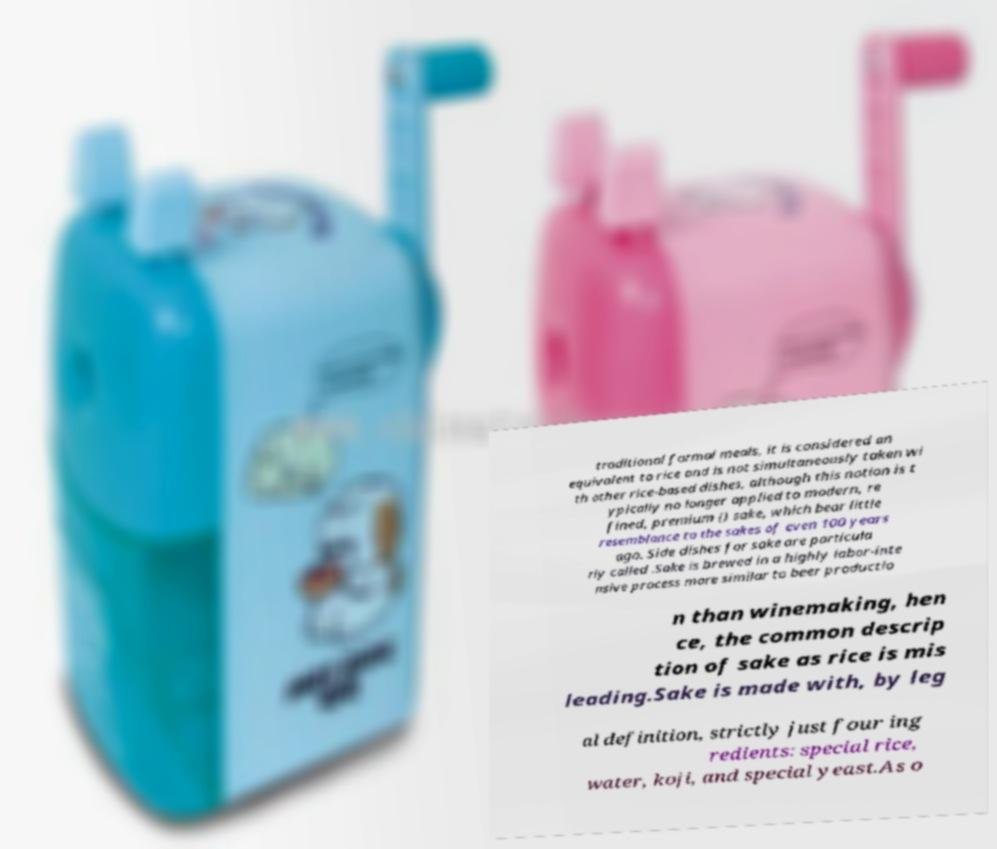Can you read and provide the text displayed in the image?This photo seems to have some interesting text. Can you extract and type it out for me? traditional formal meals, it is considered an equivalent to rice and is not simultaneously taken wi th other rice-based dishes, although this notion is t ypically no longer applied to modern, re fined, premium () sake, which bear little resemblance to the sakes of even 100 years ago. Side dishes for sake are particula rly called .Sake is brewed in a highly labor-inte nsive process more similar to beer productio n than winemaking, hen ce, the common descrip tion of sake as rice is mis leading.Sake is made with, by leg al definition, strictly just four ing redients: special rice, water, koji, and special yeast.As o 